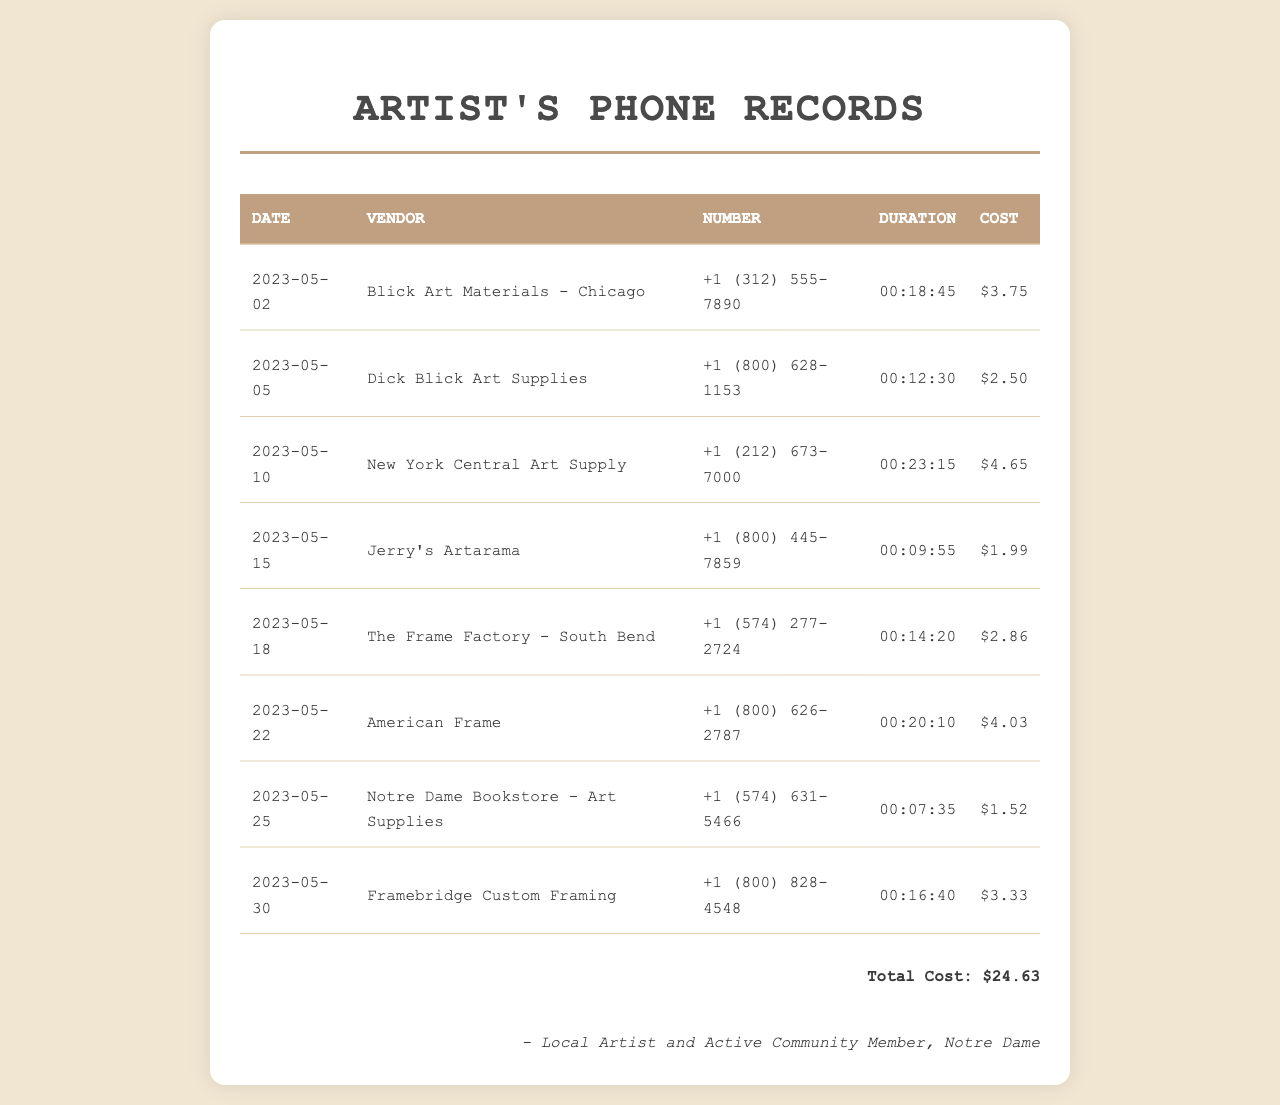What is the total cost of the long-distance calls? The total cost is listed at the end of the document, summing the individual costs of each call.
Answer: $24.63 Which vendor was called on May 10, 2023? The record lists the vendor associated with that date in the table.
Answer: New York Central Art Supply How long was the longest call duration? By comparing the durations of the calls, we find the longest one.
Answer: 00:23:15 What was the cost of the call to Blick Art Materials? The cost is shown alongside the vendor information in the records.
Answer: $3.75 How many calls were made to framing services? The document provides a table where the relevant calls can be counted.
Answer: 3 What is the phone number for Jerry's Artarama? The document lists the phone numbers alongside the vendors' names.
Answer: +1 (800) 445-7859 Which date had the shortest call duration? By evaluating the durations, we can determine the date of the shortest call.
Answer: 2023-05-25 What is the total duration of all calls made? The total duration can be calculated by summing the individual call durations provided.
Answer: 02:43:30 How many unique vendors were called? Each row of the table represents a unique vendor, which can be counted.
Answer: 8 